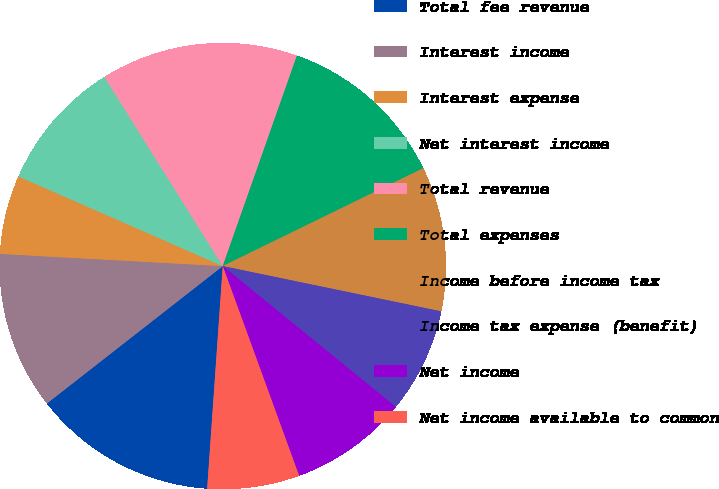Convert chart. <chart><loc_0><loc_0><loc_500><loc_500><pie_chart><fcel>Total fee revenue<fcel>Interest income<fcel>Interest expense<fcel>Net interest income<fcel>Total revenue<fcel>Total expenses<fcel>Income before income tax<fcel>Income tax expense (benefit)<fcel>Net income<fcel>Net income available to common<nl><fcel>13.33%<fcel>11.43%<fcel>5.71%<fcel>9.52%<fcel>14.29%<fcel>12.38%<fcel>10.48%<fcel>7.62%<fcel>8.57%<fcel>6.67%<nl></chart> 